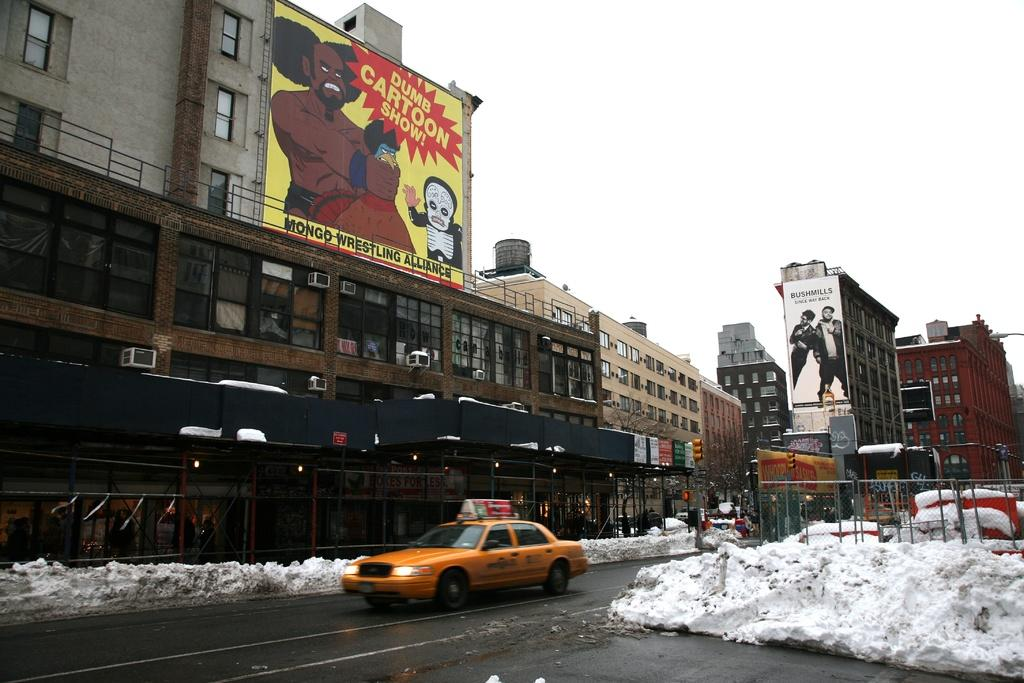<image>
Provide a brief description of the given image. A yellow cab drives down a snowy street below a sign for something called Dumb Cartoon Show. 